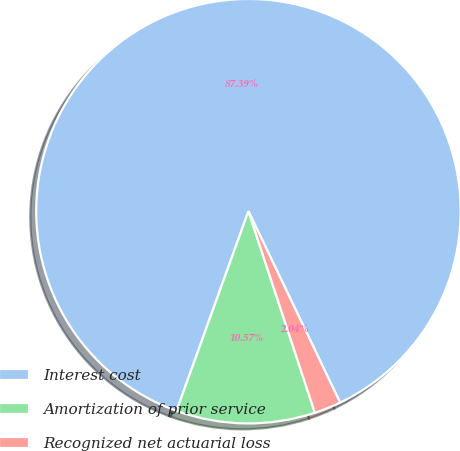Convert chart to OTSL. <chart><loc_0><loc_0><loc_500><loc_500><pie_chart><fcel>Interest cost<fcel>Amortization of prior service<fcel>Recognized net actuarial loss<nl><fcel>87.39%<fcel>10.57%<fcel>2.04%<nl></chart> 